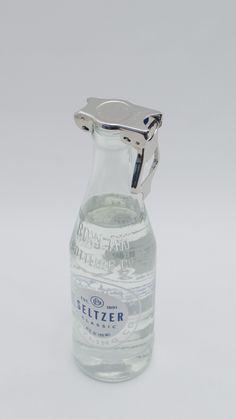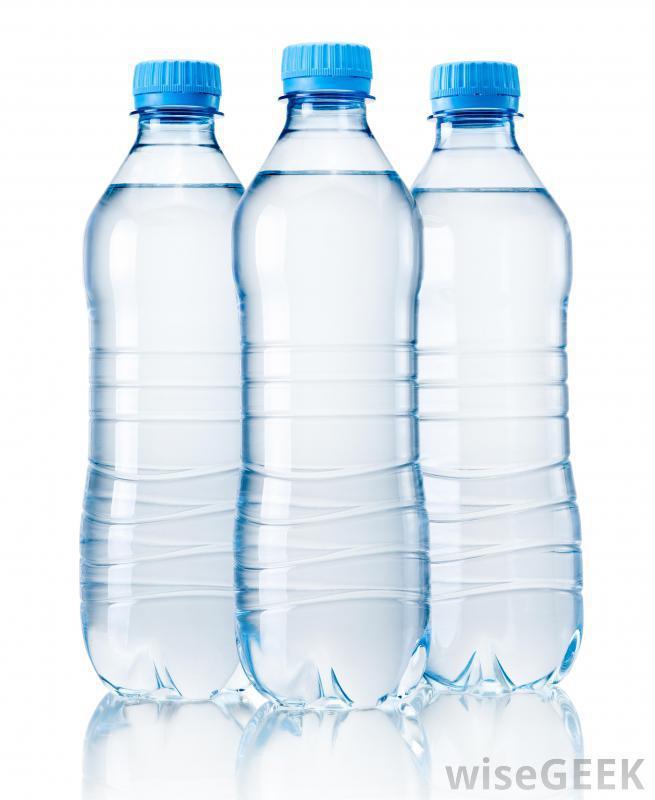The first image is the image on the left, the second image is the image on the right. Considering the images on both sides, is "The left image contains no more than one bottle." valid? Answer yes or no. Yes. The first image is the image on the left, the second image is the image on the right. Evaluate the accuracy of this statement regarding the images: "Three water bottles with blue caps are in a row.". Is it true? Answer yes or no. Yes. 